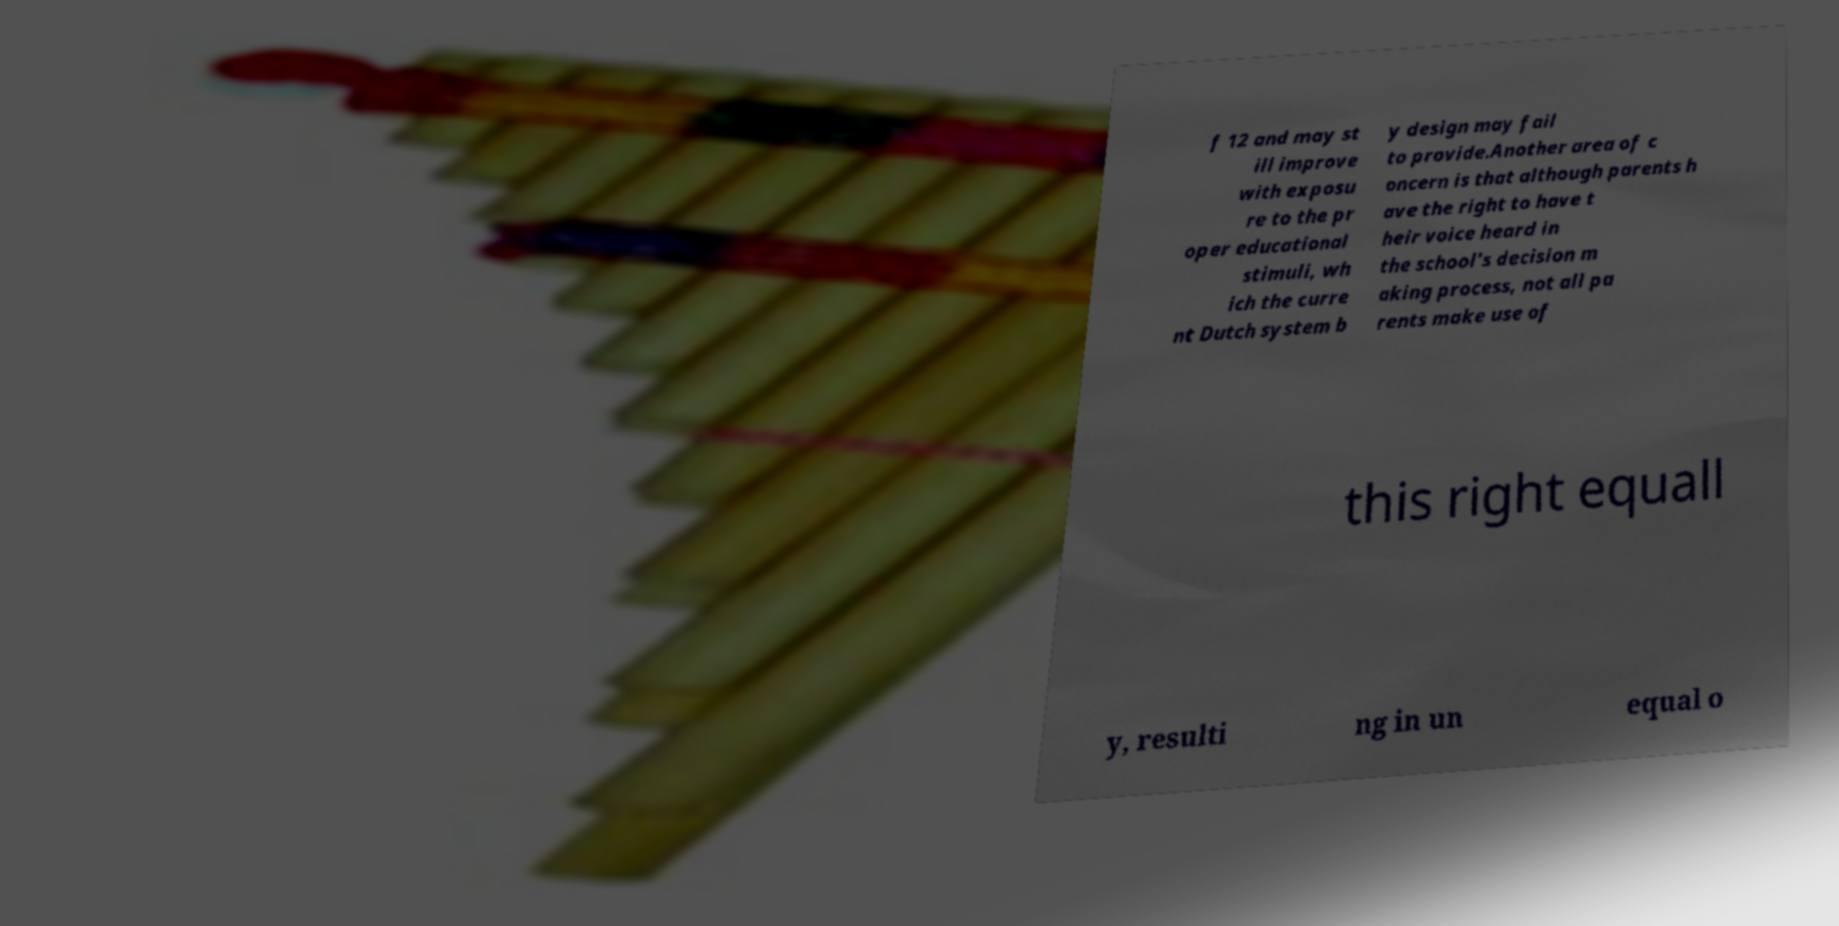There's text embedded in this image that I need extracted. Can you transcribe it verbatim? f 12 and may st ill improve with exposu re to the pr oper educational stimuli, wh ich the curre nt Dutch system b y design may fail to provide.Another area of c oncern is that although parents h ave the right to have t heir voice heard in the school's decision m aking process, not all pa rents make use of this right equall y, resulti ng in un equal o 